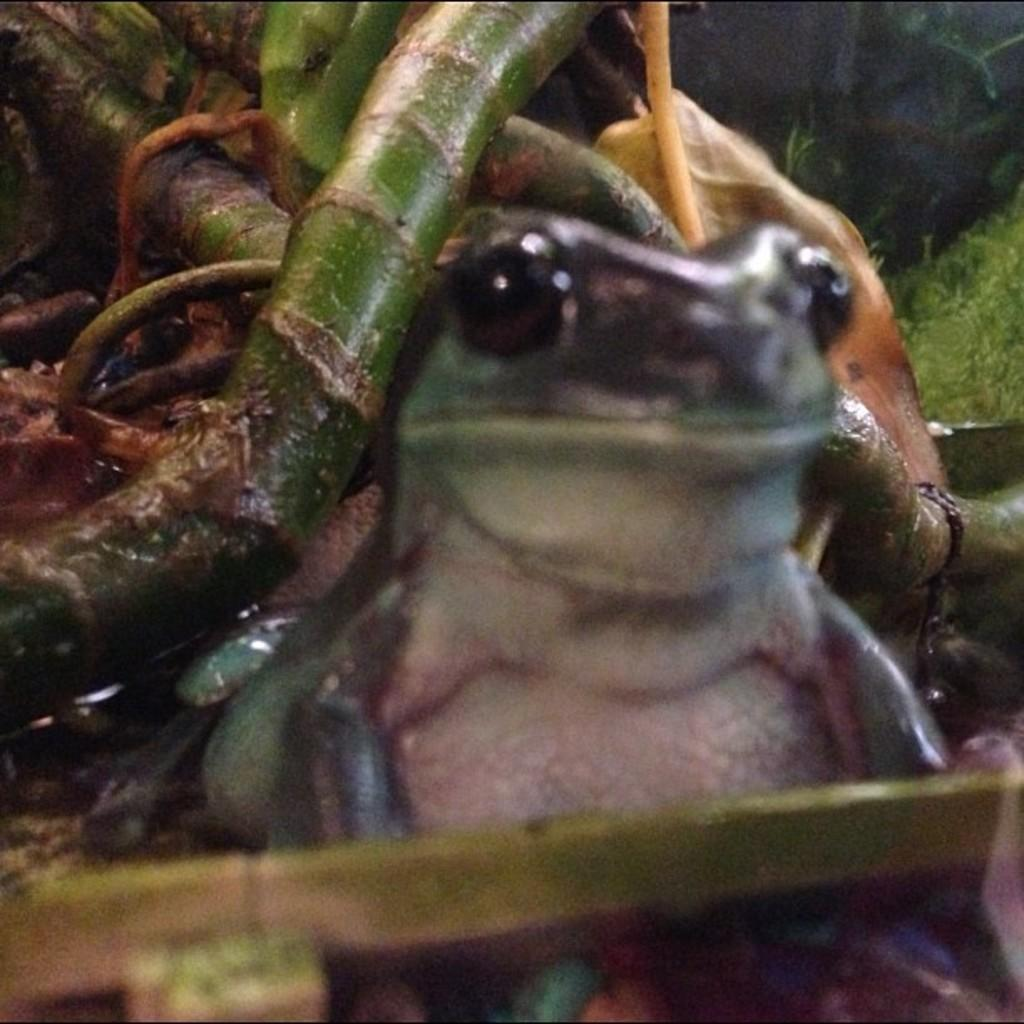What animal is present in the image? There is a frog in the image. Where is the frog located in the image? The frog is on the ground. What type of notebook is the frog using in the image? There is no notebook present in the image, as it features a frog on the ground. 